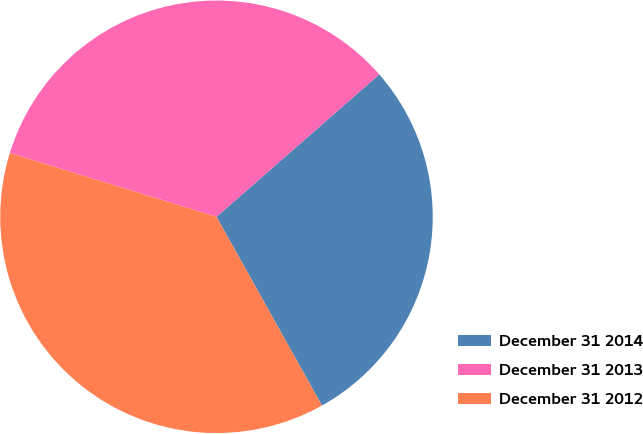Convert chart. <chart><loc_0><loc_0><loc_500><loc_500><pie_chart><fcel>December 31 2014<fcel>December 31 2013<fcel>December 31 2012<nl><fcel>28.33%<fcel>33.8%<fcel>37.87%<nl></chart> 